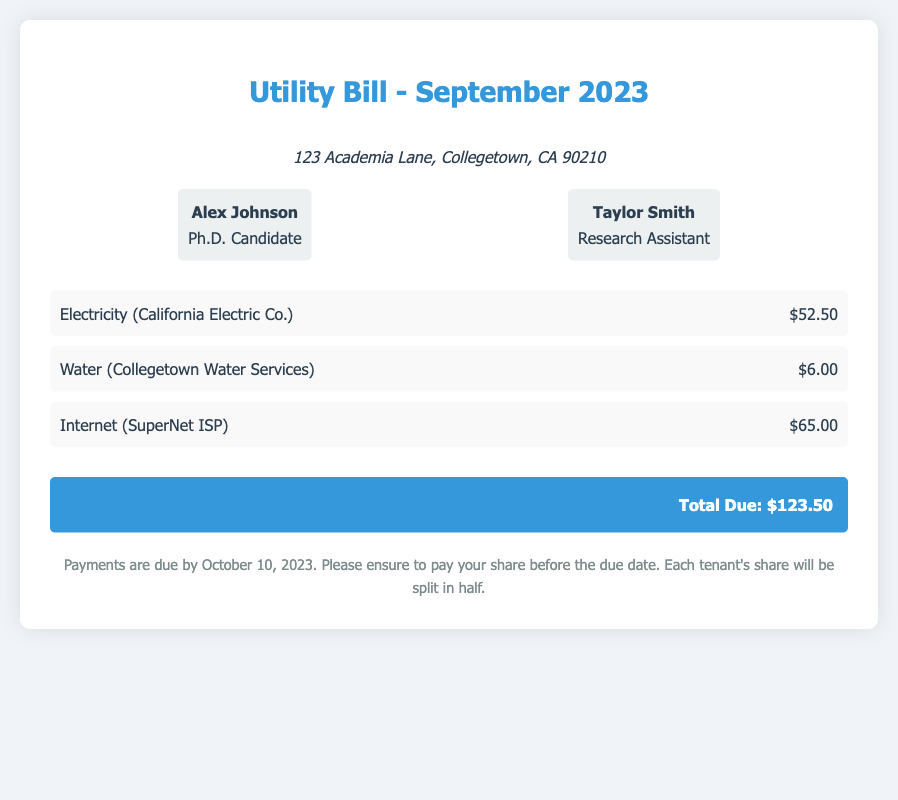What is the total due amount? The total due amount is listed at the bottom of the document summary, which is the total of all charges.
Answer: $123.50 Who is the provider of the electricity service? The document specifies the provider of the electricity service under the charges section.
Answer: California Electric Co What is the water charge? The water charge is mentioned in the breakdown of charges in the document.
Answer: $6.00 How many tenants are mentioned in the bill? The document lists the tenants involved, which can be counted in the tenants section.
Answer: 2 What is the due date for the payment? The due date for the payment is noted in the notes section of the document.
Answer: October 10, 2023 What is Taylor Smith's role? Taylor Smith's role is stated in the tenants section alongside their name.
Answer: Research Assistant What is the charge for the internet? The charge for the internet is included in the breakdown of charges.
Answer: $65.00 What is the address mentioned in the document? The address is provided at the top of the document, under the address section.
Answer: 123 Academia Lane, Collegetown, CA 90210 